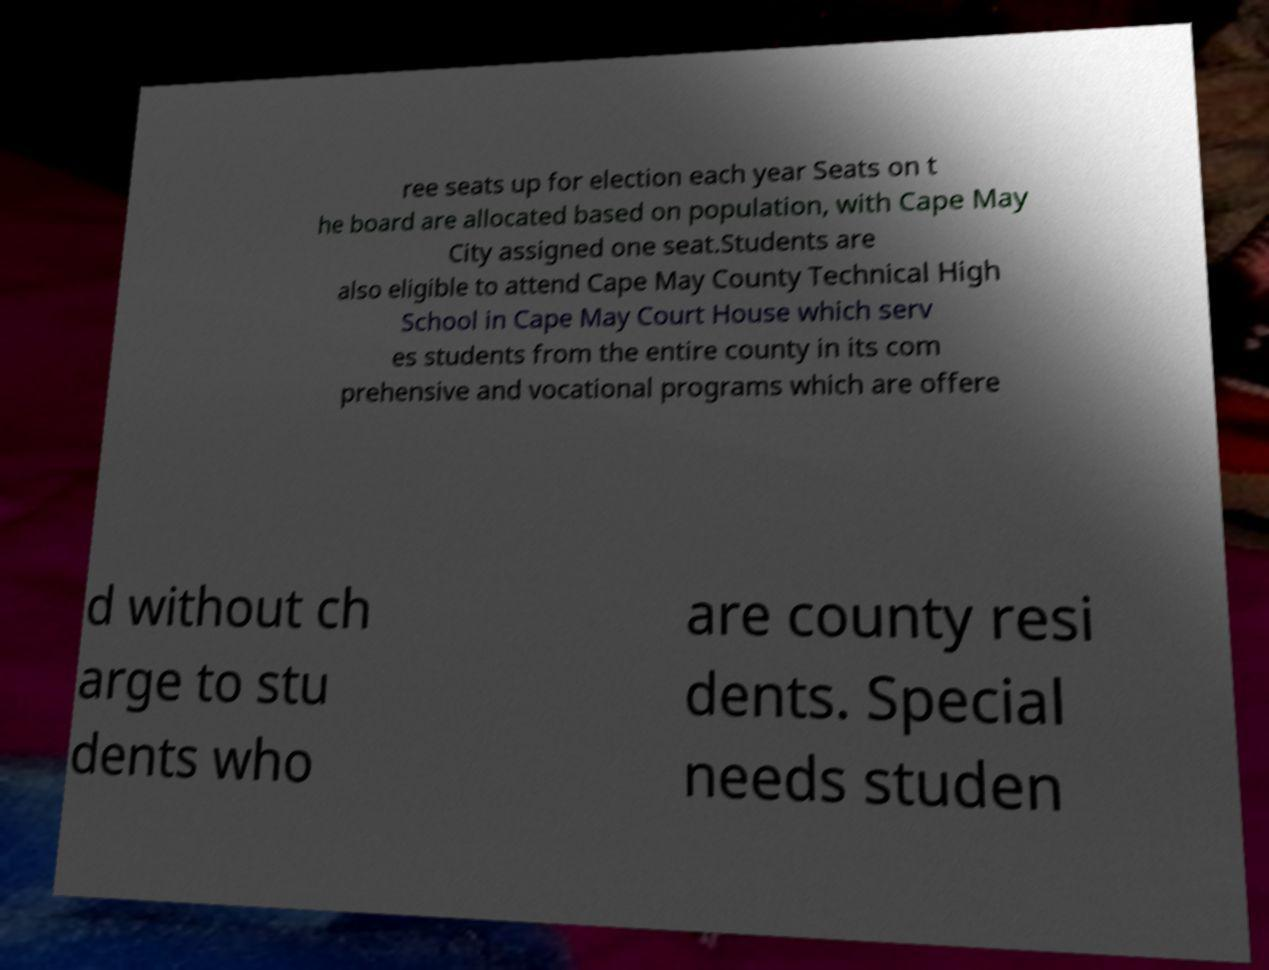I need the written content from this picture converted into text. Can you do that? ree seats up for election each year Seats on t he board are allocated based on population, with Cape May City assigned one seat.Students are also eligible to attend Cape May County Technical High School in Cape May Court House which serv es students from the entire county in its com prehensive and vocational programs which are offere d without ch arge to stu dents who are county resi dents. Special needs studen 